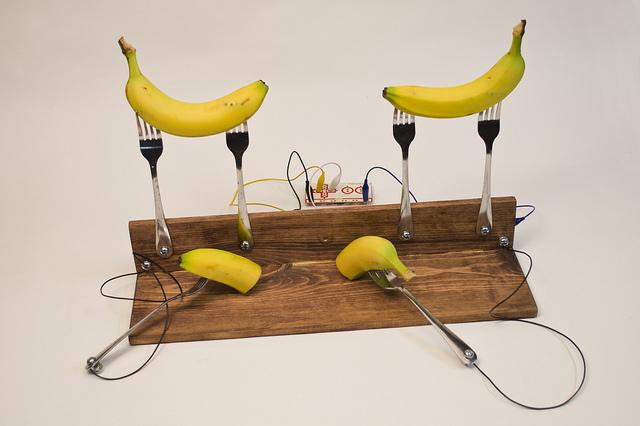Why are there wires running from the forks?
Write a very short answer. Electricity. How many forks are upright?
Short answer required. 4. What fruit is on the contraption?
Short answer required. Banana. 